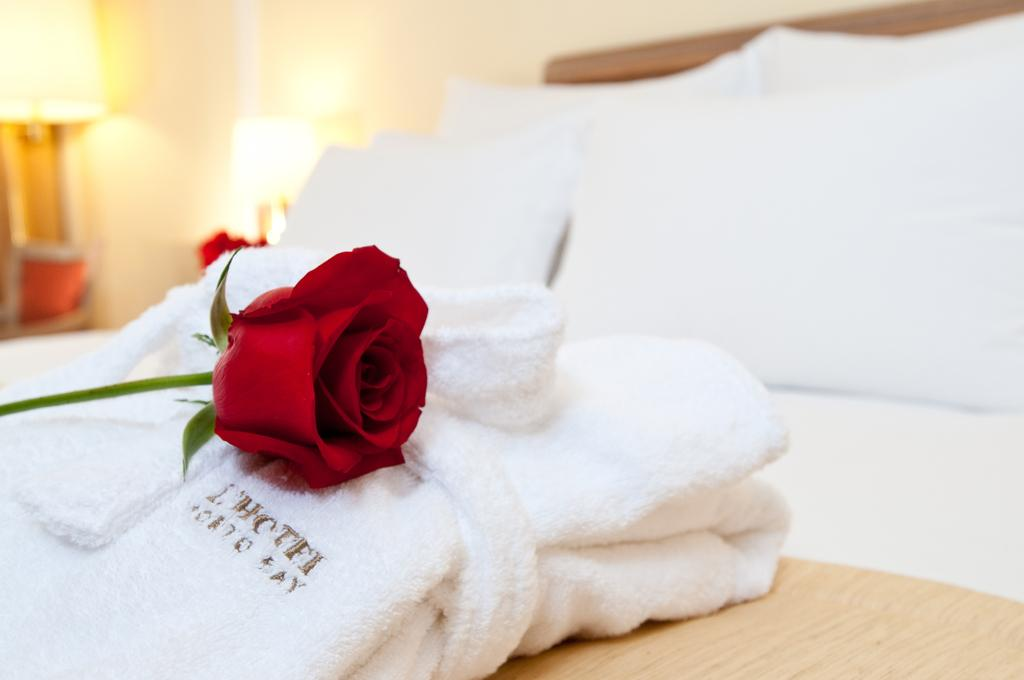What piece of furniture is present in the image? There is a bed in the image. What covers the bed? There are there any decorations on it? What objects can be seen in the top left of the image? There are lamps in the top left of the image. What is visible in the background of the image? There is a wall visible in the image. How many hands are holding the jar on the bed? There is no jar or hands present in the image. 